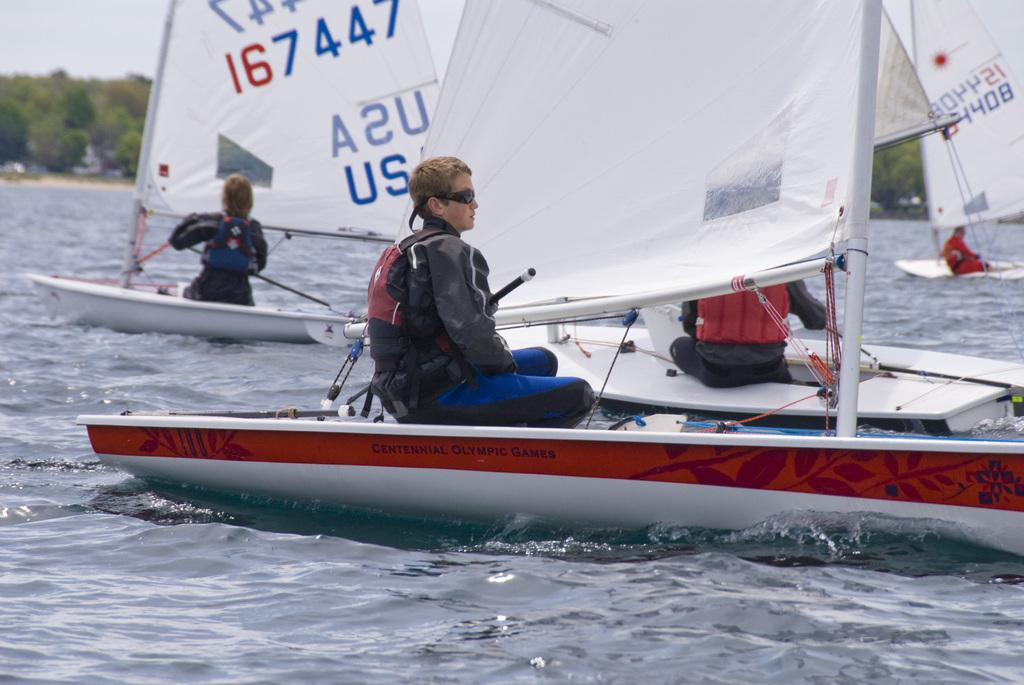What are the people in the image doing? The people in the image are in boats. What is the primary element the boats are sailing on? The boats are sailing on the water. What can be seen in the background of the image? Trees and the sky are visible in the background of the image. What type of division can be seen between the boats in the image? There is no division between the boats in the image; they are sailing on the water. Can you identify any boundaries in the image? There are no boundaries explicitly mentioned or visible in the image. 